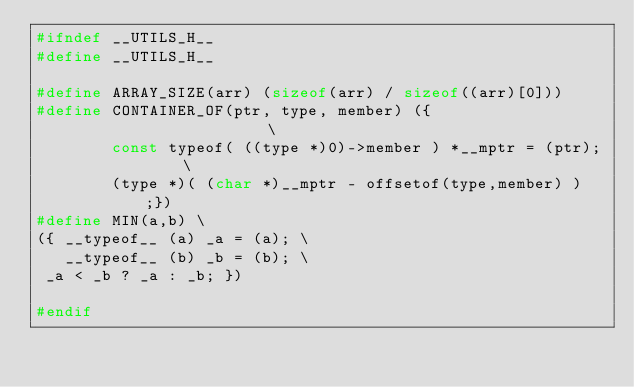Convert code to text. <code><loc_0><loc_0><loc_500><loc_500><_C_>#ifndef __UTILS_H__
#define __UTILS_H__

#define ARRAY_SIZE(arr) (sizeof(arr) / sizeof((arr)[0]))
#define CONTAINER_OF(ptr, type, member) ({                      \
        const typeof( ((type *)0)->member ) *__mptr = (ptr);    \
        (type *)( (char *)__mptr - offsetof(type,member) );})
#define MIN(a,b) \
({ __typeof__ (a) _a = (a); \
   __typeof__ (b) _b = (b); \
 _a < _b ? _a : _b; })

#endif
</code> 